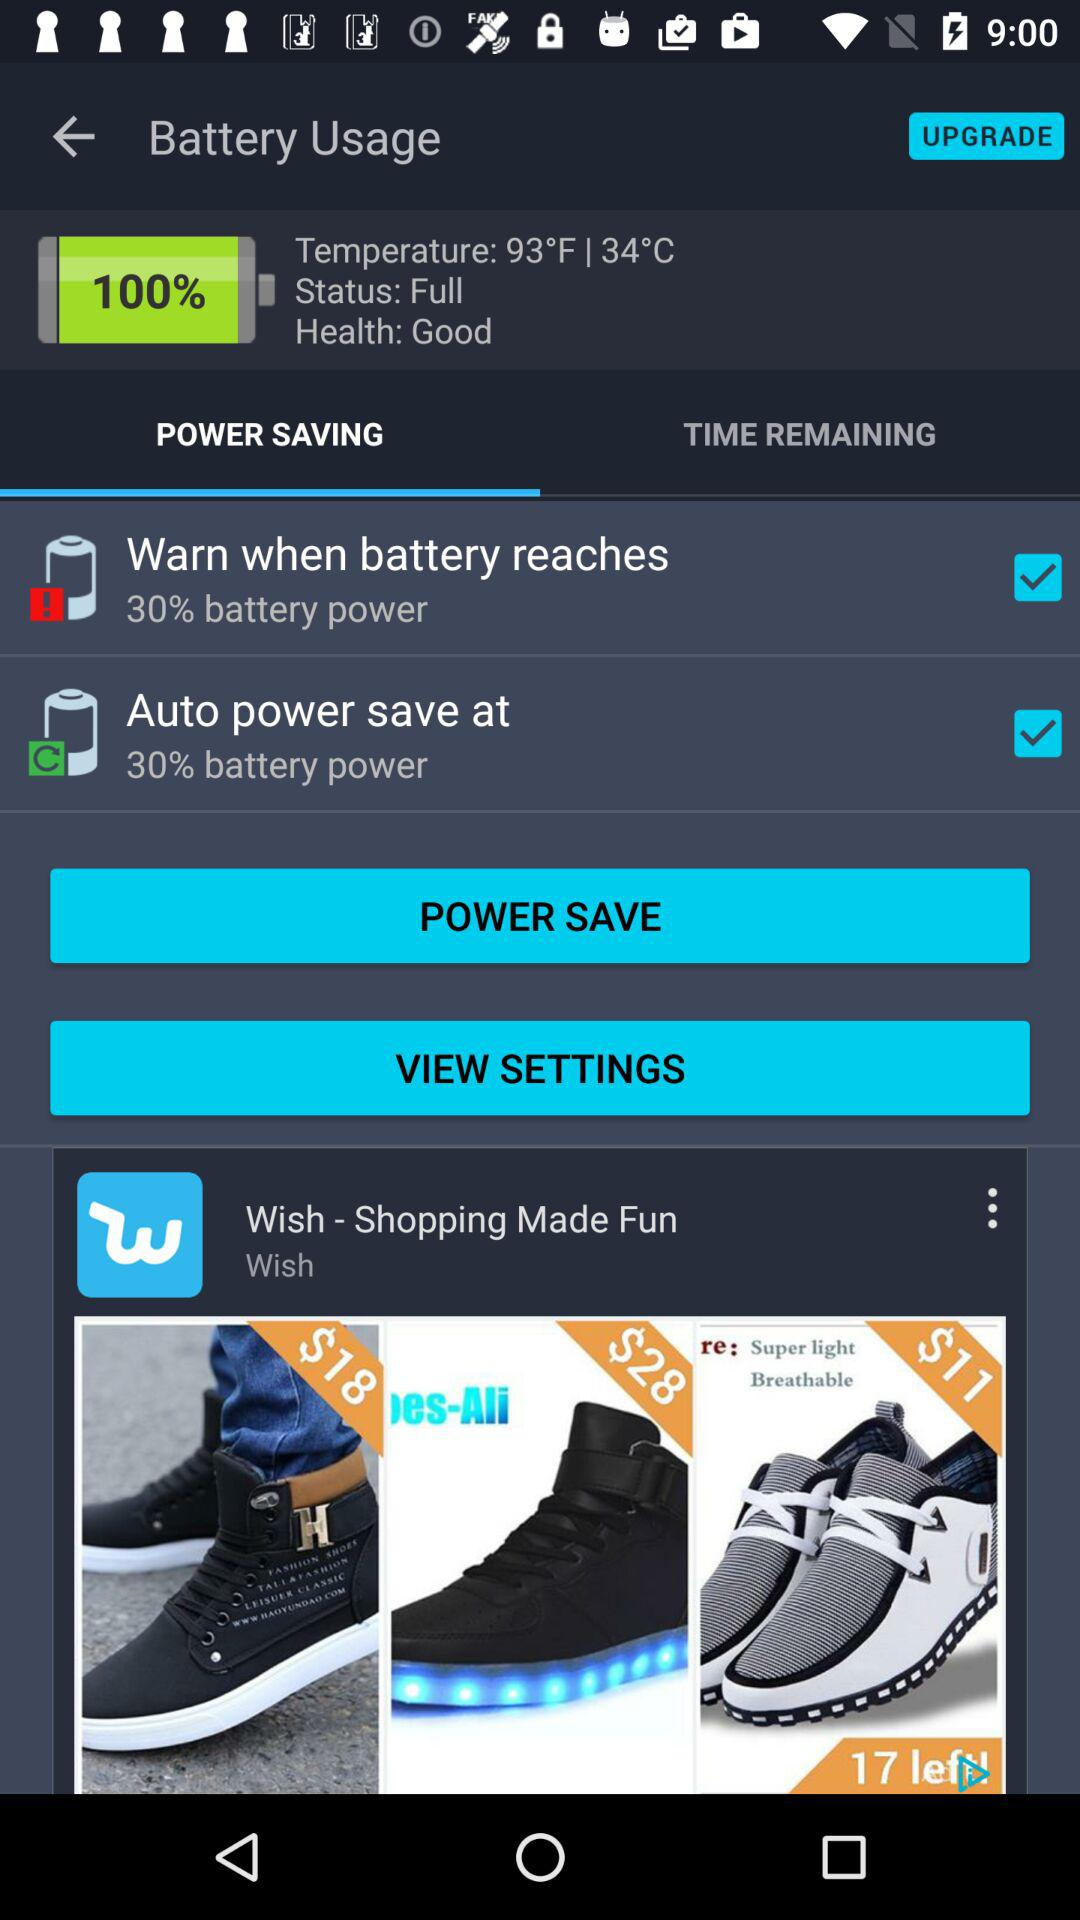How much more does the $28 pair of shoes cost than the $18 pair of shoes?
Answer the question using a single word or phrase. $10 